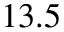Convert formula to latex. <formula><loc_0><loc_0><loc_500><loc_500>1 3 . 5</formula> 